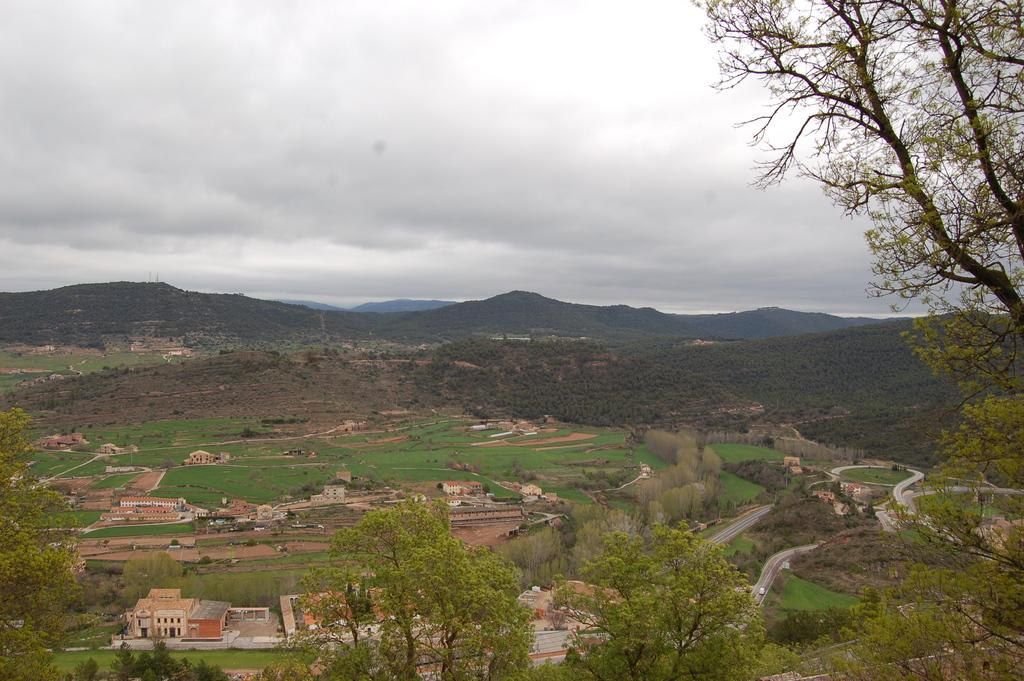What type of view is shown in the image? The image is an aerial view. What natural features can be seen in the image? Hills and trees are visible in the image. What man-made features can be seen in the image? Roads, buildings, and grass are visible in the image. What is visible in the sky at the top of the image? Clouds are present in the sky at the top of the image. What type of jar is visible on the border of the image? There is no jar present in the image, and there is no border visible in the aerial view. 